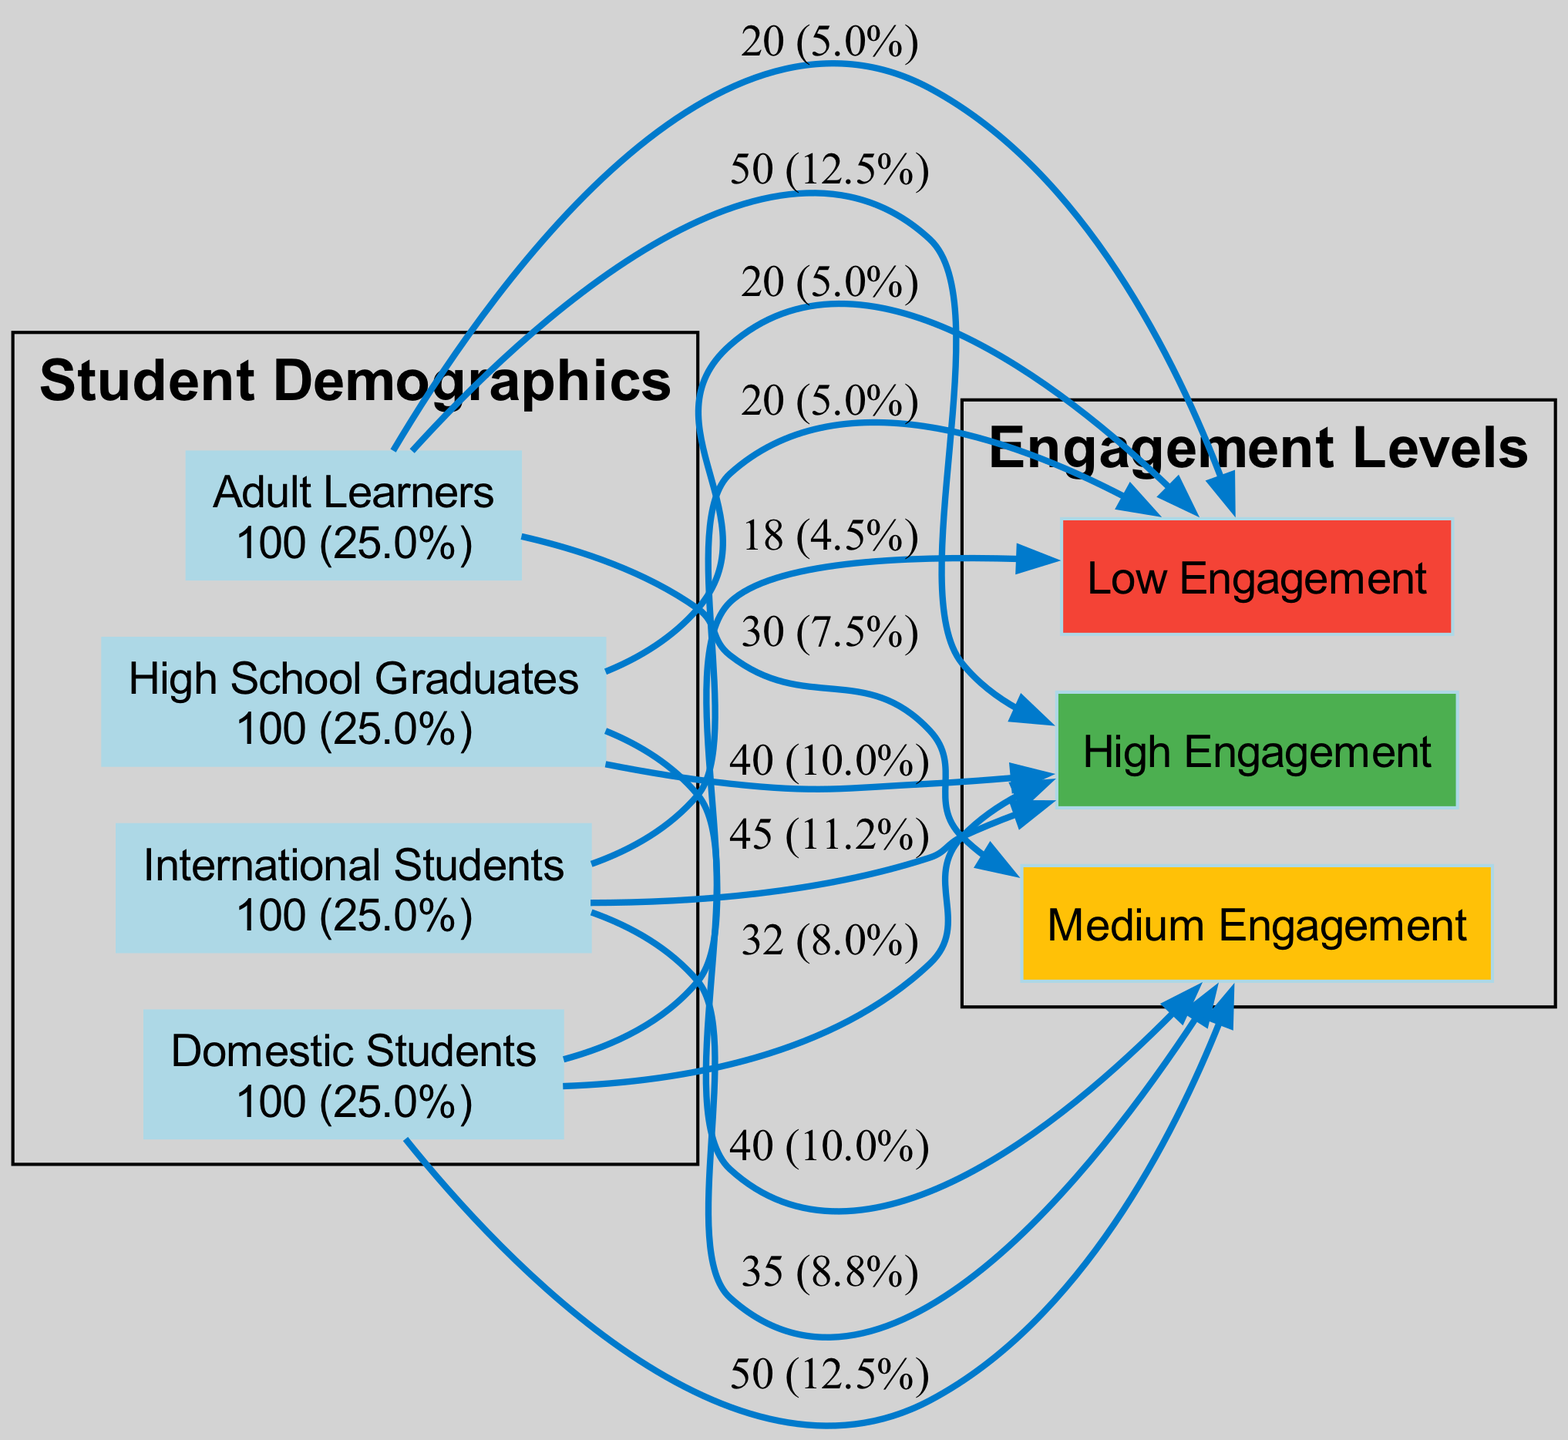What is the total number of High Engagement students? To find the total number of High Engagement students, we sum the values of High Engagement from each student demographic: 45 (International Students) + 32 (Domestic Students) + 50 (Adult Learners) + 40 (High School Graduates) = 167.
Answer: 167 Which demographic has the lowest number of Low Engagement students? We need to compare the number of Low Engagement students across all demographics: 20 (International Students), 18 (Domestic Students), 20 (Adult Learners), and 20 (High School Graduates). The lowest is 18 from Domestic Students.
Answer: Domestic Students What percentage of Adult Learners have High Engagement? To find the percentage, we take the number of High Engagement Adult Learners (50) and divide it by the total number of Adult Learners. The total is 50 + 30 + 20 = 100. Therefore, the percentage is (50/100) * 100% = 50%.
Answer: 50% How many engagement levels are represented in the diagram? There are three engagement levels depicted in the diagram: High Engagement, Medium Engagement, and Low Engagement. Counting these gives us a total of 3 levels.
Answer: 3 What is the ratio of High Engagement to Low Engagement students among High School Graduates? For High School Graduates, High Engagement is 40 and Low Engagement is 20. The ratio is calculated as 40:20, which simplifies to 2:1.
Answer: 2:1 Which demographic has the highest total number of students? We calculate the total number of students for each demographic: International Students (45 + 35 + 20 = 100), Domestic Students (32 + 50 + 18 = 100), Adult Learners (50 + 30 + 20 = 100), and High School Graduates (40 + 40 + 20 = 100). All demographics have equal totals of 100.
Answer: All demographics How does Medium Engagement compare between the Domestic and Adult Learners groups? The number of Medium Engagement students are 50 (Domestic Students) and 30 (Adult Learners). Comparing these two values, Domestic Students have higher Medium Engagement with 50 compared to 30.
Answer: Domestic Students What is the total number of students across all demographics? To find the total number of students, we add the total students from each demographic: 100 (International Students) + 100 (Domestic Students) + 100 (Adult Learners) + 100 (High School Graduates) = 400.
Answer: 400 